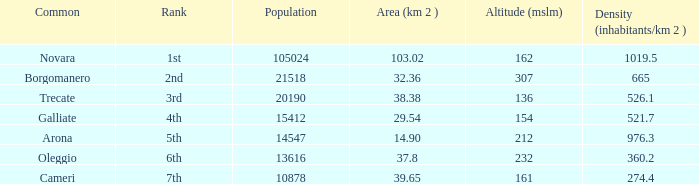Parse the full table. {'header': ['Common', 'Rank', 'Population', 'Area (km 2 )', 'Altitude (mslm)', 'Density (inhabitants/km 2 )'], 'rows': [['Novara', '1st', '105024', '103.02', '162', '1019.5'], ['Borgomanero', '2nd', '21518', '32.36', '307', '665'], ['Trecate', '3rd', '20190', '38.38', '136', '526.1'], ['Galliate', '4th', '15412', '29.54', '154', '521.7'], ['Arona', '5th', '14547', '14.90', '212', '976.3'], ['Oleggio', '6th', '13616', '37.8', '232', '360.2'], ['Cameri', '7th', '10878', '39.65', '161', '274.4']]} Where does the common of Galliate rank in population? 4th. 